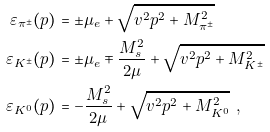<formula> <loc_0><loc_0><loc_500><loc_500>\varepsilon _ { \pi ^ { \pm } } ( p ) & = \pm \mu _ { e } + \sqrt { v ^ { 2 } p ^ { 2 } + M ^ { 2 } _ { \pi ^ { \pm } } } \\ \varepsilon _ { K ^ { \pm } } ( p ) & = \pm \mu _ { e } \mp \frac { M _ { s } ^ { 2 } } { 2 \mu } + \sqrt { v ^ { 2 } p ^ { 2 } + M ^ { 2 } _ { K ^ { \pm } } } \\ \varepsilon _ { K ^ { 0 } } ( p ) & = - \frac { M _ { s } ^ { 2 } } { 2 \mu } + \sqrt { v ^ { 2 } p ^ { 2 } + M ^ { 2 } _ { K ^ { 0 } } } \ ,</formula> 